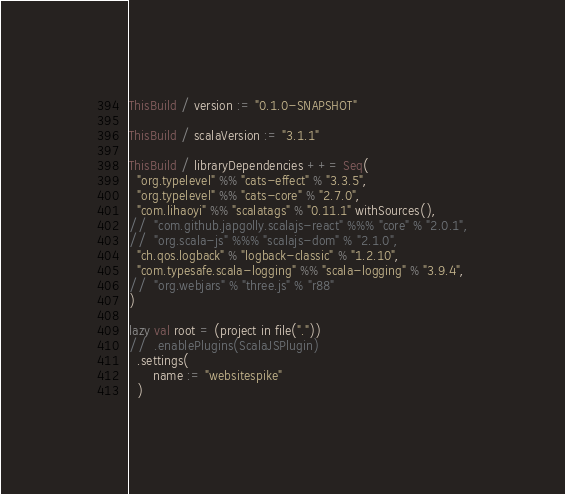<code> <loc_0><loc_0><loc_500><loc_500><_Scala_>ThisBuild / version := "0.1.0-SNAPSHOT"

ThisBuild / scalaVersion := "3.1.1"

ThisBuild / libraryDependencies ++= Seq(
  "org.typelevel" %% "cats-effect" % "3.3.5",
  "org.typelevel" %% "cats-core" % "2.7.0",
  "com.lihaoyi" %% "scalatags" % "0.11.1" withSources(),
//  "com.github.japgolly.scalajs-react" %%% "core" % "2.0.1",
//  "org.scala-js" %%% "scalajs-dom" % "2.1.0",
  "ch.qos.logback" % "logback-classic" % "1.2.10",
  "com.typesafe.scala-logging" %% "scala-logging" % "3.9.4",
//  "org.webjars" % "three.js" % "r88"
)

lazy val root = (project in file("."))
//  .enablePlugins(ScalaJSPlugin)
  .settings(
      name := "websitespike"
  )
</code> 